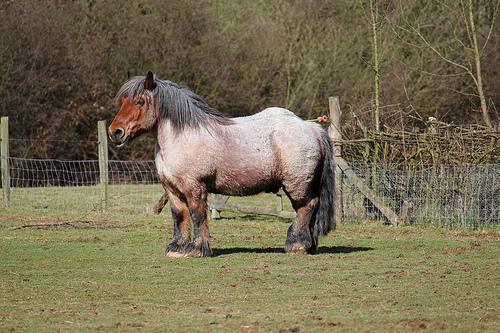How many horses are photographed?
Give a very brief answer. 1. 